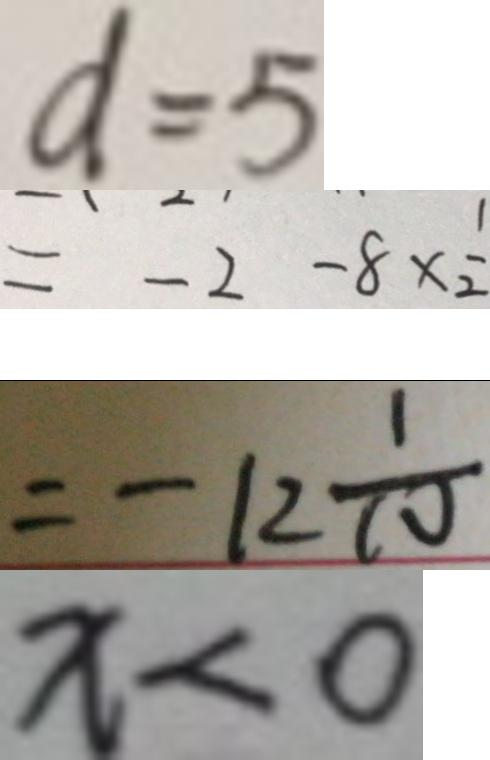<formula> <loc_0><loc_0><loc_500><loc_500>d = 5 
 = - 2 - 8 \times \frac { 1 } { 2 } 
 = - 1 2 \frac { 1 } { 1 0 } 
 x < 0</formula> 